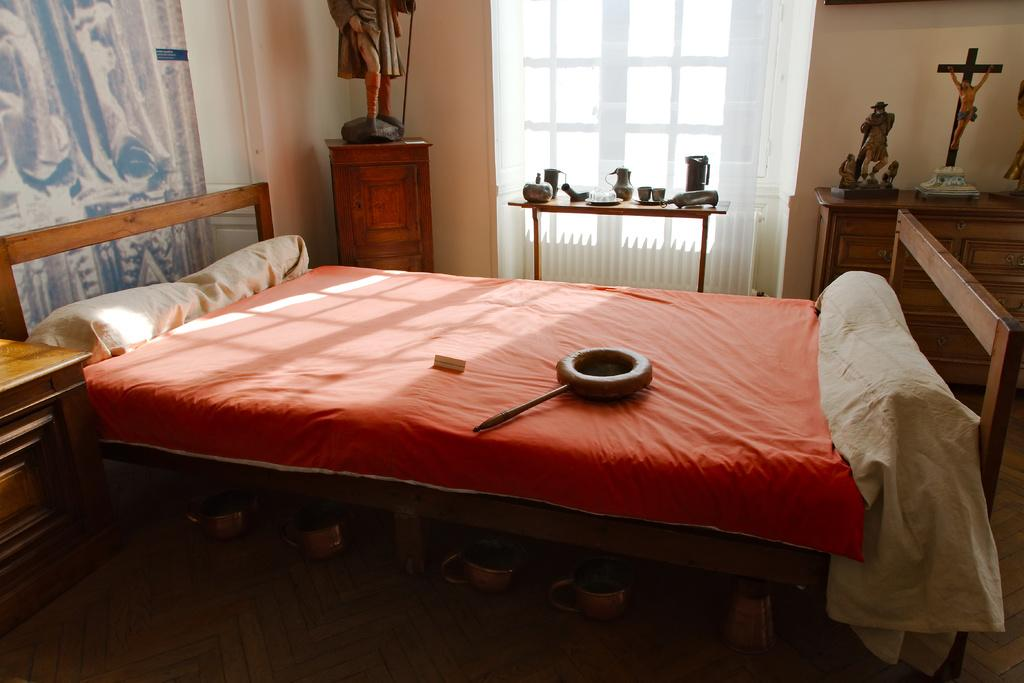What piece of furniture is the main subject in the image? There is a bed in the image. What is located under the bed? There are utensils under the bed. What type of storage furniture is present in the image? There are drawers in the image. What other piece of furniture is in the image? There is a table in the image. What is placed on the table? There are things on the table. What architectural feature is visible in the image? There is a window in the image. What type of window treatment is present? There is a curtain associated with the window. What type of decorative item is in the image? There is a sculpture in the image. What type of marble is used to make the cub on the table in the image? There is no marble or cub present on the table in the image. 